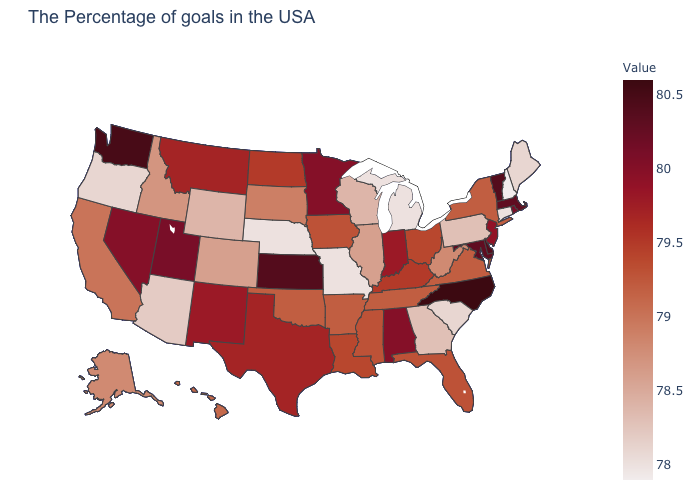Which states have the lowest value in the MidWest?
Write a very short answer. Michigan, Missouri, Nebraska. Which states have the lowest value in the USA?
Be succinct. New Hampshire. Is the legend a continuous bar?
Short answer required. Yes. Is the legend a continuous bar?
Keep it brief. Yes. Among the states that border Oregon , which have the lowest value?
Write a very short answer. Idaho. Is the legend a continuous bar?
Write a very short answer. Yes. Does Oregon have the lowest value in the USA?
Answer briefly. No. Does Vermont have the highest value in the Northeast?
Answer briefly. Yes. Does Rhode Island have a higher value than North Carolina?
Keep it brief. No. 